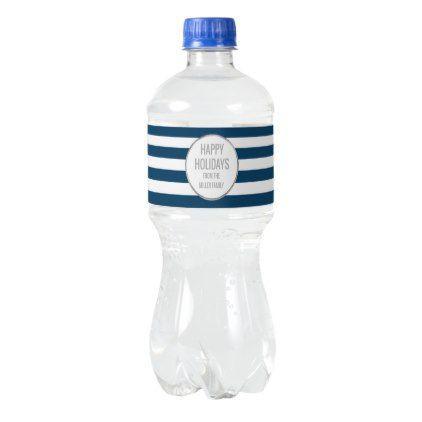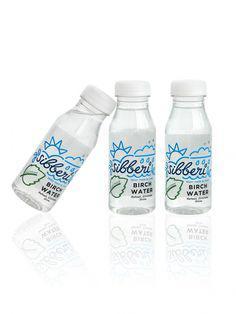The first image is the image on the left, the second image is the image on the right. Considering the images on both sides, is "The bottle on the left has a blue and white striped label and there are at least three bottles on the right hand image." valid? Answer yes or no. Yes. The first image is the image on the left, the second image is the image on the right. Evaluate the accuracy of this statement regarding the images: "In one image, three bottles have white caps and identical labels, while the second image has one or more bottles with dark caps and different labeling.". Is it true? Answer yes or no. Yes. 